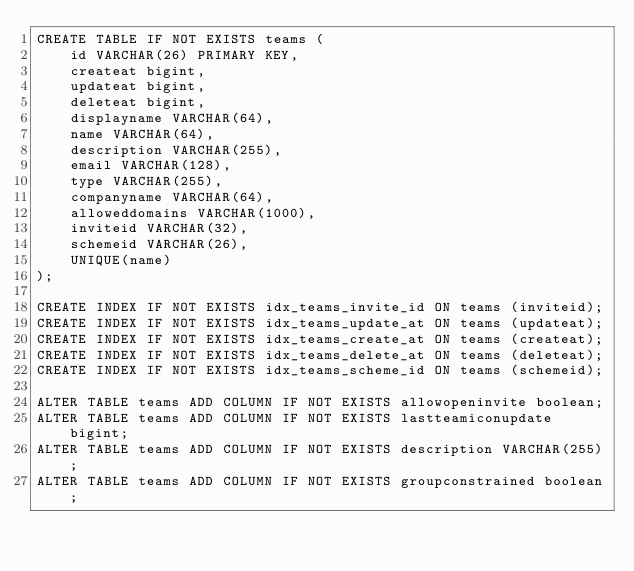<code> <loc_0><loc_0><loc_500><loc_500><_SQL_>CREATE TABLE IF NOT EXISTS teams (
    id VARCHAR(26) PRIMARY KEY,
    createat bigint,
    updateat bigint,
    deleteat bigint,
    displayname VARCHAR(64),
    name VARCHAR(64),
    description VARCHAR(255),
    email VARCHAR(128),
    type VARCHAR(255),
    companyname VARCHAR(64),
    alloweddomains VARCHAR(1000),
    inviteid VARCHAR(32),
    schemeid VARCHAR(26),
    UNIQUE(name)
);

CREATE INDEX IF NOT EXISTS idx_teams_invite_id ON teams (inviteid);
CREATE INDEX IF NOT EXISTS idx_teams_update_at ON teams (updateat);
CREATE INDEX IF NOT EXISTS idx_teams_create_at ON teams (createat);
CREATE INDEX IF NOT EXISTS idx_teams_delete_at ON teams (deleteat);
CREATE INDEX IF NOT EXISTS idx_teams_scheme_id ON teams (schemeid);

ALTER TABLE teams ADD COLUMN IF NOT EXISTS allowopeninvite boolean;
ALTER TABLE teams ADD COLUMN IF NOT EXISTS lastteamiconupdate bigint;
ALTER TABLE teams ADD COLUMN IF NOT EXISTS description VARCHAR(255);
ALTER TABLE teams ADD COLUMN IF NOT EXISTS groupconstrained boolean;
</code> 